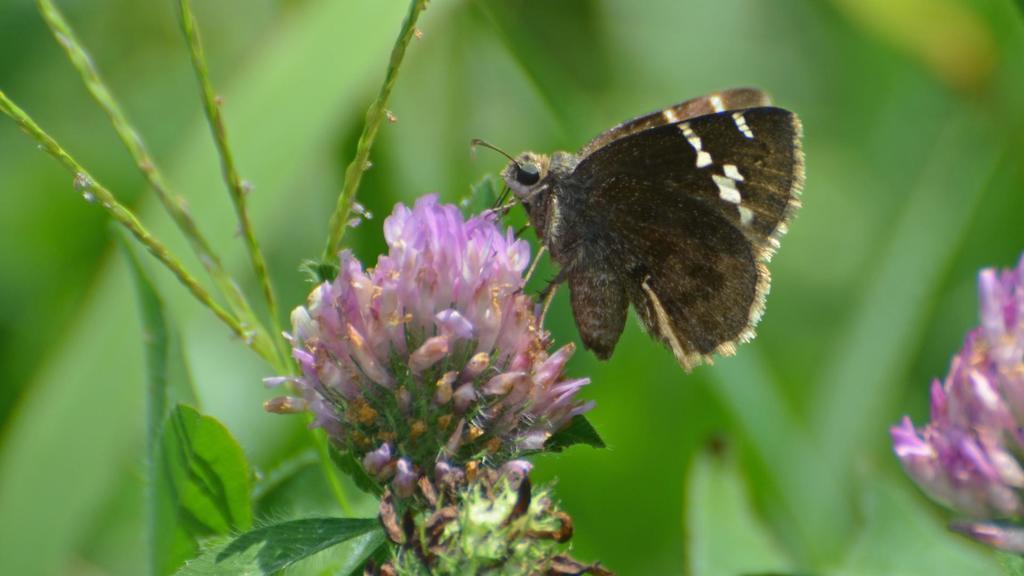In one or two sentences, can you explain what this image depicts? This image consists of a butterfly on a flower. The flower is in pink color. The background is blurred and it is in green color. 